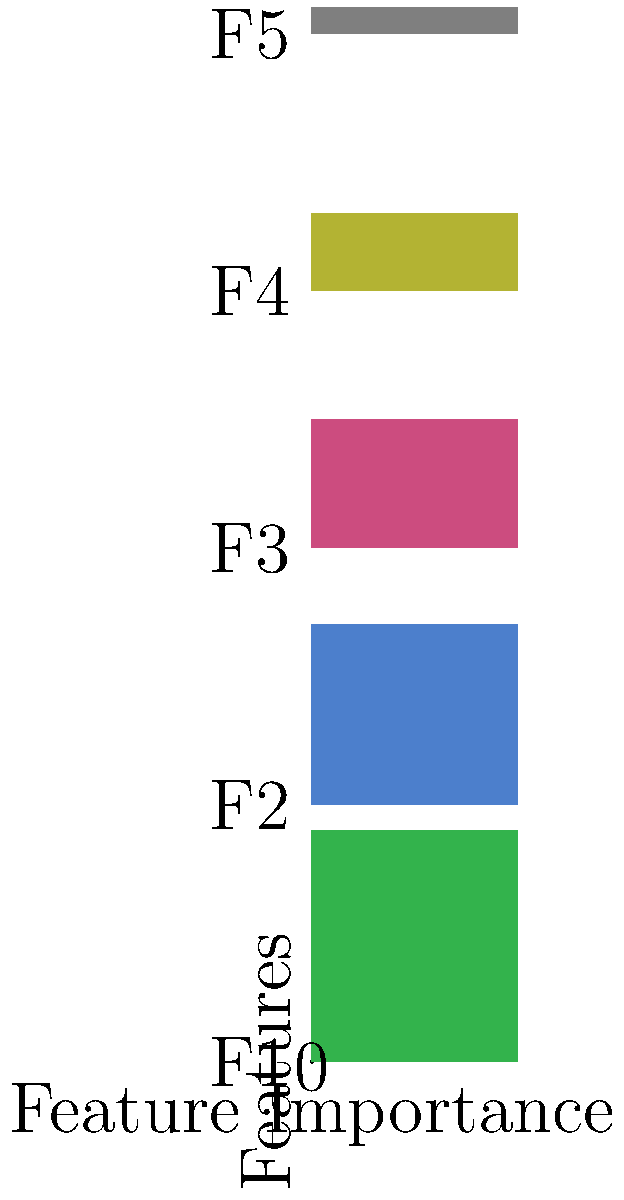Given the feature importance graph for a decision tree within a random forest ensemble, which feature contributes the most to the model's predictions, and how would you quantify its relative importance compared to the least important feature? To answer this question, we need to analyze the feature importance graph and follow these steps:

1. Identify the most important feature:
   - F1 has the longest bar, indicating it has the highest importance score.

2. Identify the least important feature:
   - F5 has the shortest bar, indicating it has the lowest importance score.

3. Quantify the relative importance:
   - We can estimate the importance scores from the graph:
     F1: 0.9
     F5: 0.1

   - To calculate the relative importance, we use the formula:
     $$ \text{Relative Importance} = \frac{\text{Importance of F1}}{\text{Importance of F5}} $$

   - Substituting the values:
     $$ \text{Relative Importance} = \frac{0.9}{0.1} = 9 $$

Therefore, feature F1 contributes the most to the model's predictions, and its relative importance is approximately 9 times that of the least important feature, F5.
Answer: F1; 9 times more important than F5 